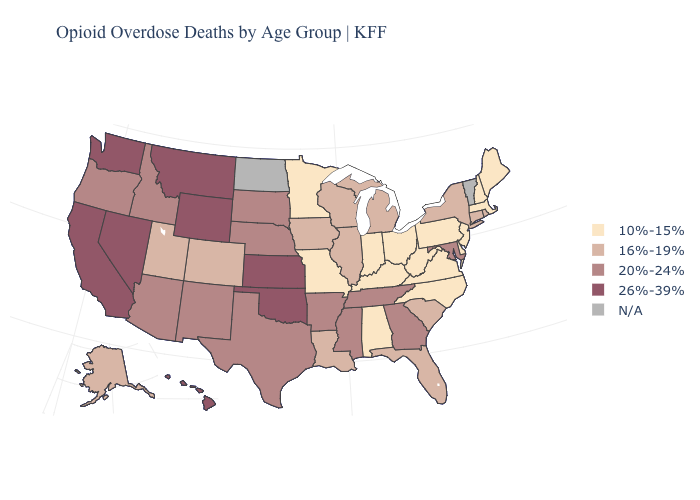Does the map have missing data?
Short answer required. Yes. What is the value of Arizona?
Short answer required. 20%-24%. Name the states that have a value in the range 20%-24%?
Write a very short answer. Arizona, Arkansas, Georgia, Idaho, Maryland, Mississippi, Nebraska, New Mexico, Oregon, South Dakota, Tennessee, Texas. Among the states that border Massachusetts , does Rhode Island have the highest value?
Give a very brief answer. Yes. Does Pennsylvania have the highest value in the Northeast?
Write a very short answer. No. What is the highest value in the MidWest ?
Quick response, please. 26%-39%. Which states have the lowest value in the USA?
Give a very brief answer. Alabama, Delaware, Indiana, Kentucky, Maine, Massachusetts, Minnesota, Missouri, New Hampshire, New Jersey, North Carolina, Ohio, Pennsylvania, Virginia, West Virginia. Name the states that have a value in the range 26%-39%?
Concise answer only. California, Hawaii, Kansas, Montana, Nevada, Oklahoma, Washington, Wyoming. What is the highest value in the West ?
Concise answer only. 26%-39%. Does Wyoming have the highest value in the USA?
Keep it brief. Yes. What is the value of Utah?
Write a very short answer. 16%-19%. What is the value of Oregon?
Write a very short answer. 20%-24%. Does Alabama have the lowest value in the South?
Be succinct. Yes. Which states have the lowest value in the West?
Concise answer only. Alaska, Colorado, Utah. Does Massachusetts have the lowest value in the USA?
Keep it brief. Yes. 